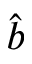Convert formula to latex. <formula><loc_0><loc_0><loc_500><loc_500>\hat { b }</formula> 